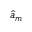<formula> <loc_0><loc_0><loc_500><loc_500>{ \hat { a } } _ { m }</formula> 